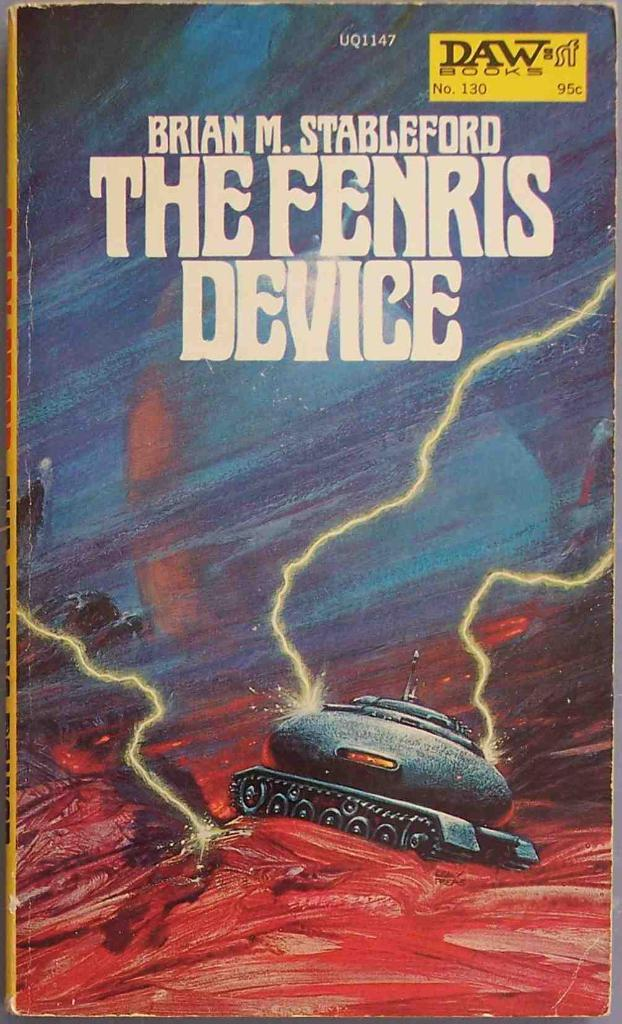<image>
Create a compact narrative representing the image presented. A book by Brian M. Stableford called The Fenris Device 